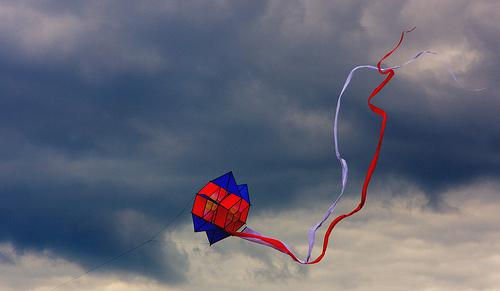Question: where was the picture taken?
Choices:
A. From the ground.
B. From the air.
C. From behind.
D. From the roof.
Answer with the letter. Answer: A Question: what color are the tails?
Choices:
A. Red and blue.
B. Red and green.
C. Orange and blue.
D. Green and orange.
Answer with the letter. Answer: A Question: what is in the sky?
Choices:
A. A bird.
B. A plane.
C. The kite.
D. Superman.
Answer with the letter. Answer: C 